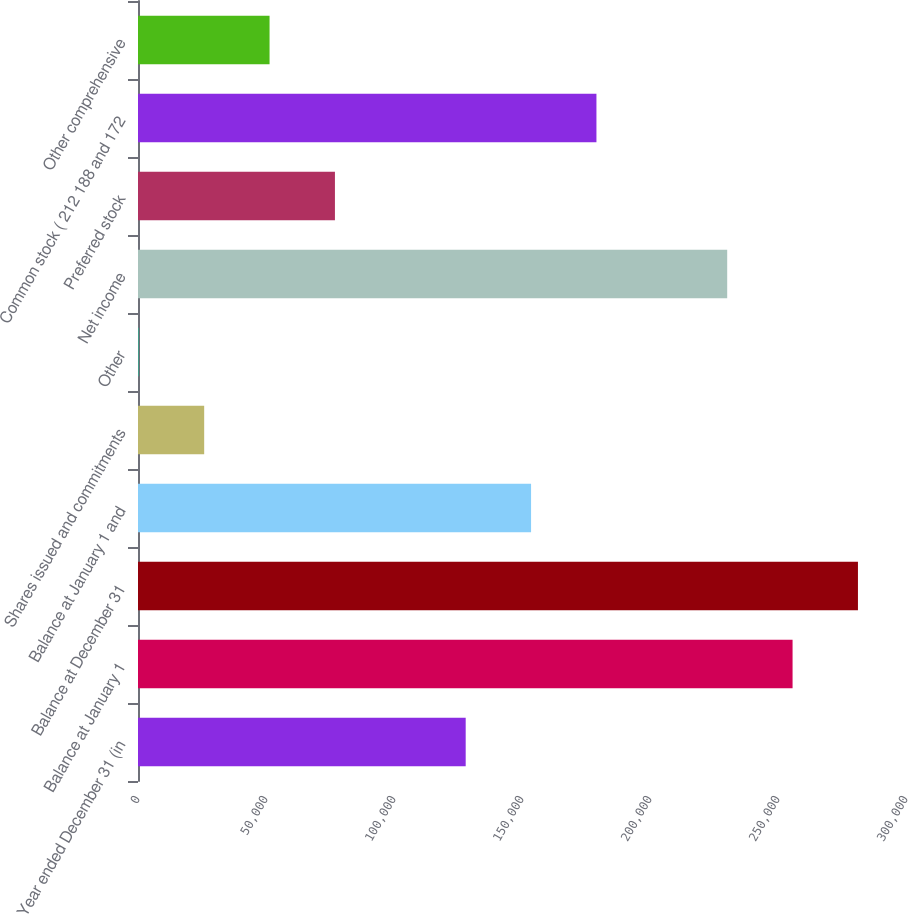Convert chart. <chart><loc_0><loc_0><loc_500><loc_500><bar_chart><fcel>Year ended December 31 (in<fcel>Balance at January 1<fcel>Balance at December 31<fcel>Balance at January 1 and<fcel>Shares issued and commitments<fcel>Other<fcel>Net income<fcel>Preferred stock<fcel>Common stock ( 212 188 and 172<fcel>Other comprehensive<nl><fcel>128004<fcel>255693<fcel>281231<fcel>153541<fcel>25851.9<fcel>314<fcel>230155<fcel>76927.7<fcel>179079<fcel>51389.8<nl></chart> 